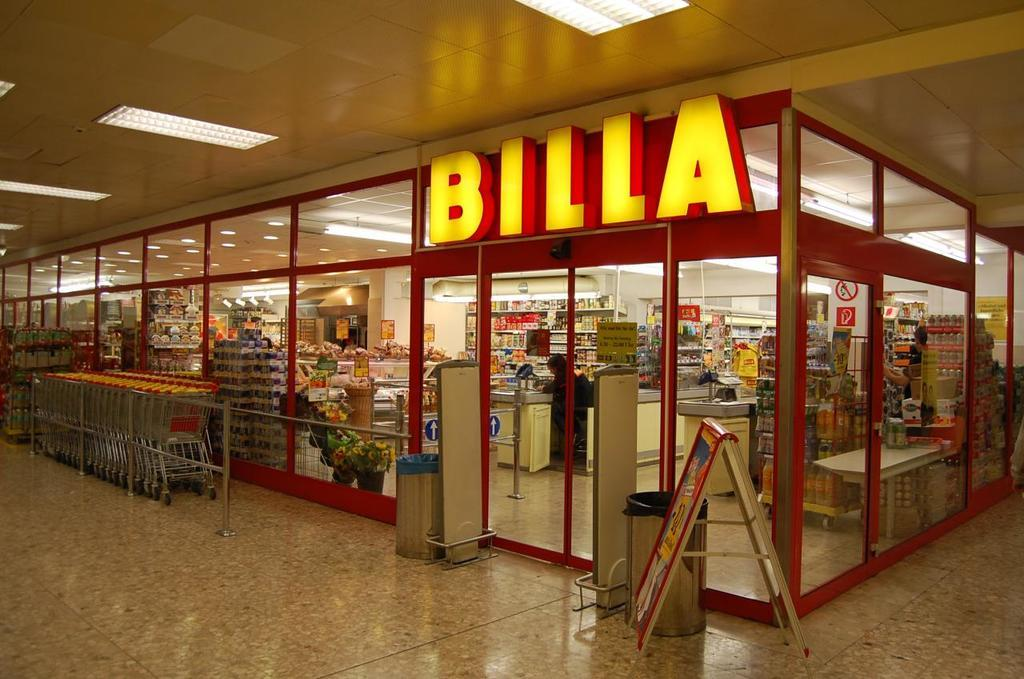Provide a one-sentence caption for the provided image. The exterior of a Billa supermarket within a shopping mall. 